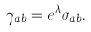<formula> <loc_0><loc_0><loc_500><loc_500>\gamma _ { a b } = e ^ { \lambda } \sigma _ { a b } .</formula> 